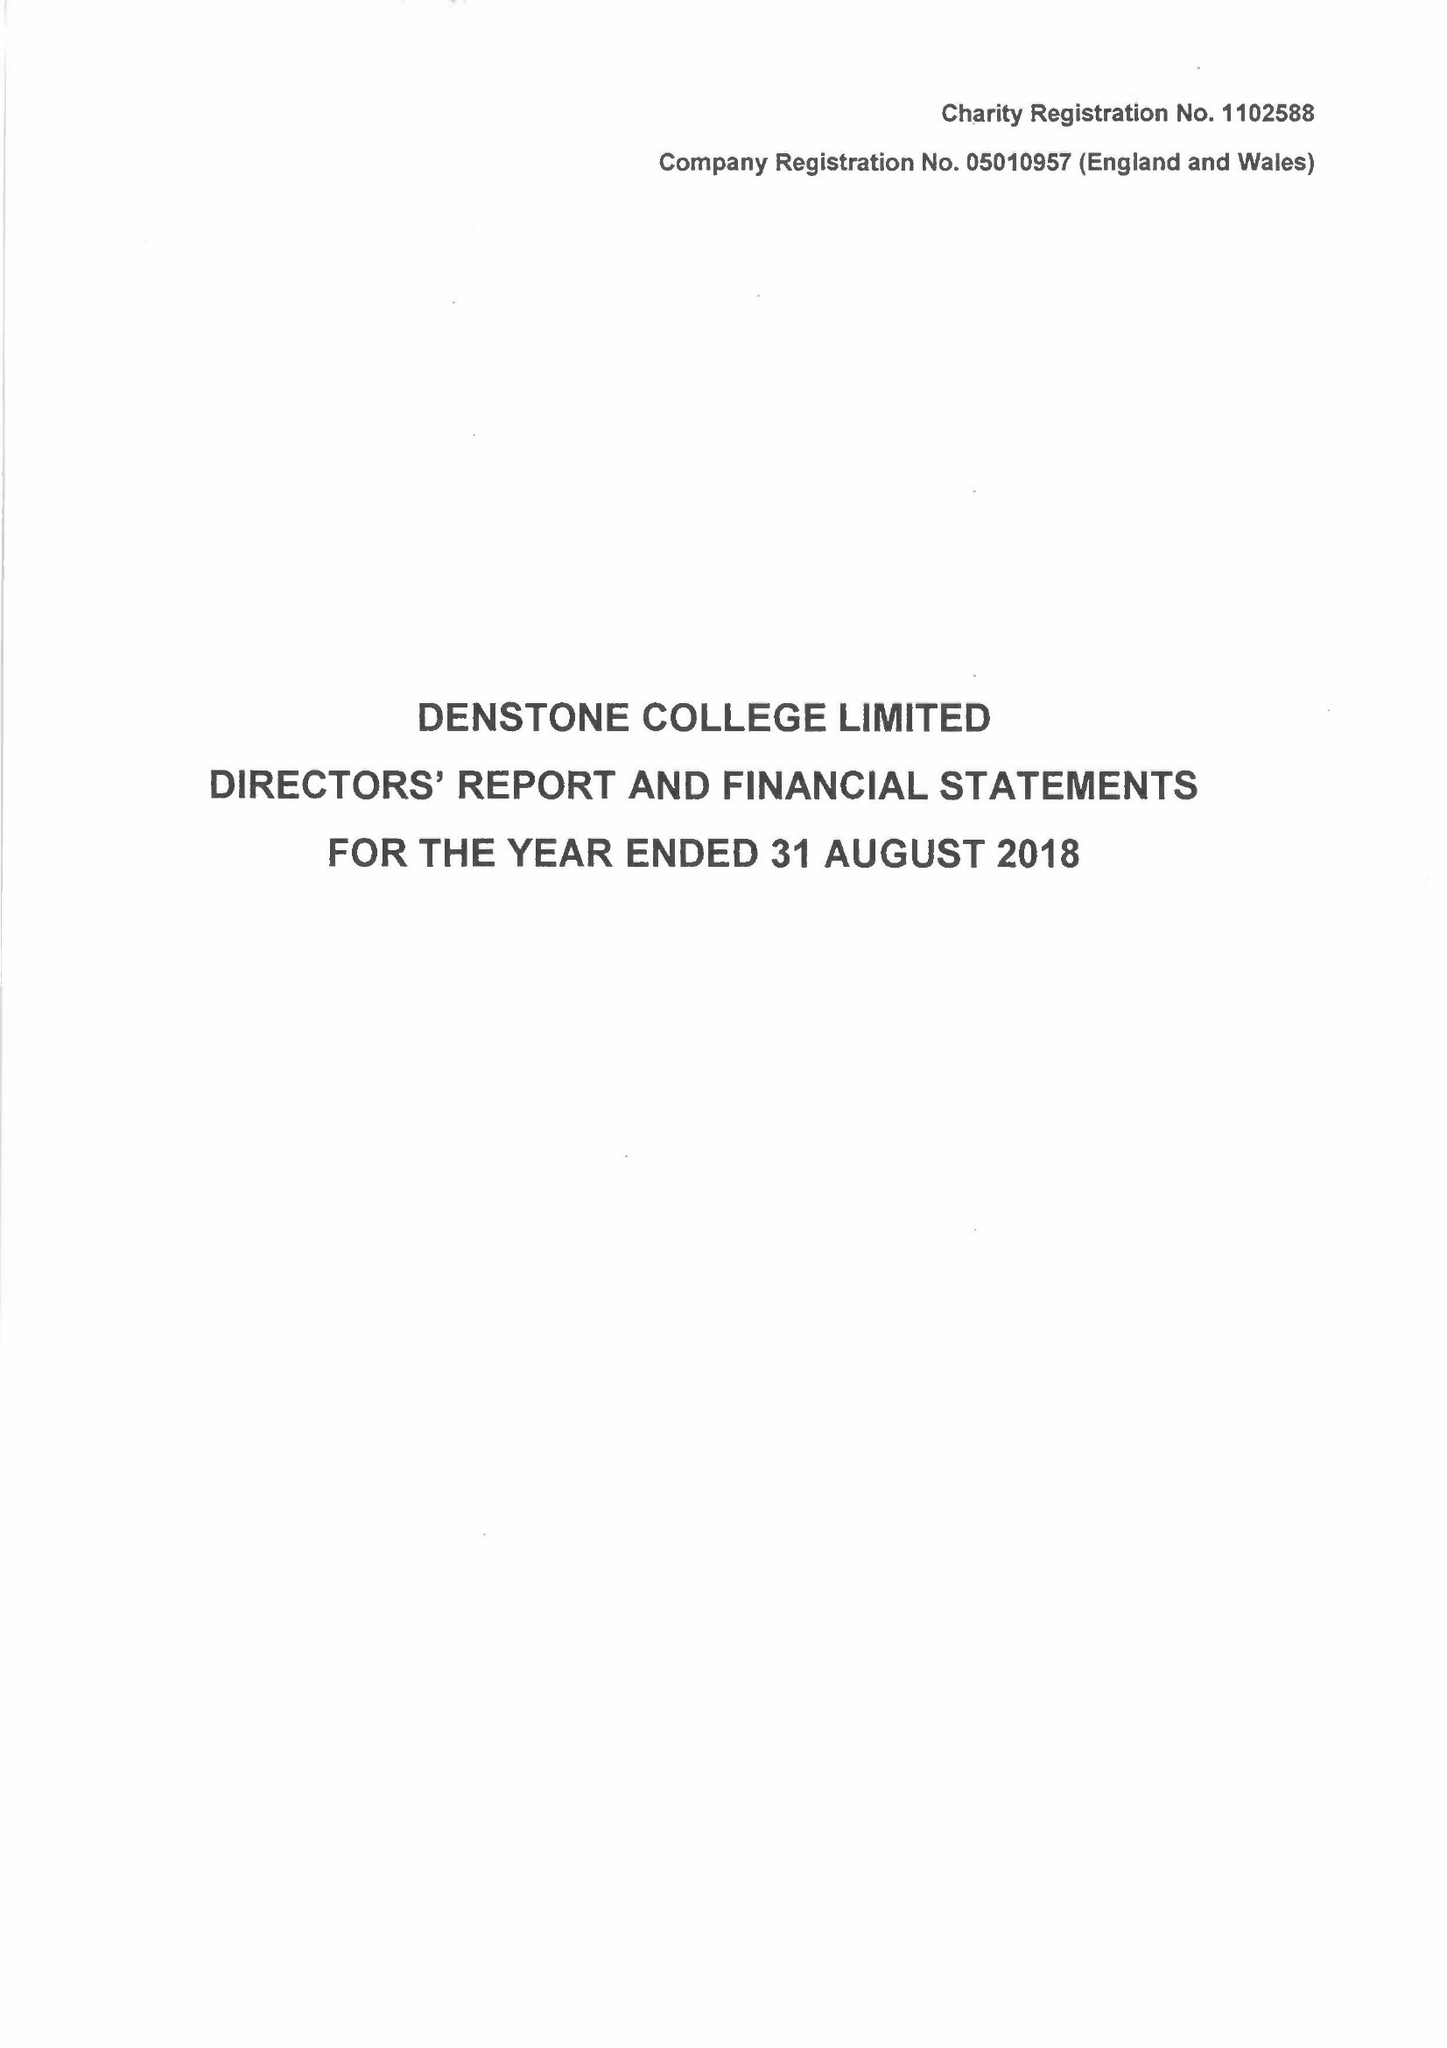What is the value for the income_annually_in_british_pounds?
Answer the question using a single word or phrase. 10310094.00 